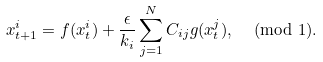Convert formula to latex. <formula><loc_0><loc_0><loc_500><loc_500>x ^ { i } _ { t + 1 } = f ( x ^ { i } _ { t } ) + \frac { \epsilon } { k _ { i } } \sum _ { j = 1 } ^ { N } C _ { i j } g ( x ^ { j } _ { t } ) , \, \pmod { 1 } .</formula> 